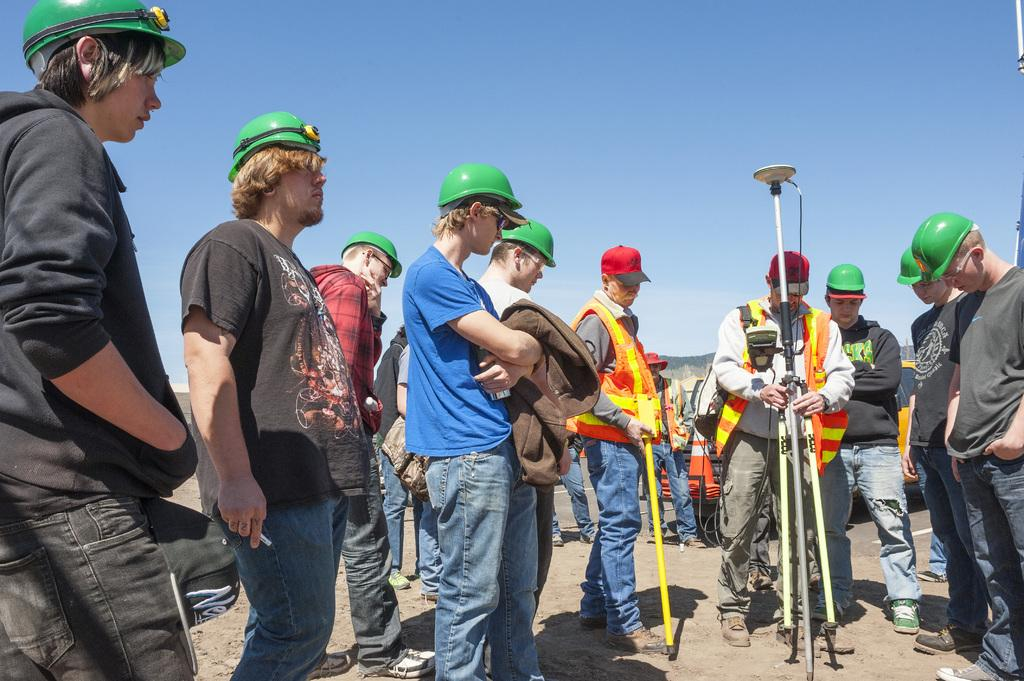What can be seen at the top of the image? The sky is visible at the top of the image. What is happening in the foreground of the image? There are people in the foreground of the image. What is one person doing in the image? One person is holding a stand. What is located behind the people in the image? There is a vehicle behind the people. What type of cable is being used by the army in the image? There is no mention of a cable or the army in the image; it features people and a vehicle. 